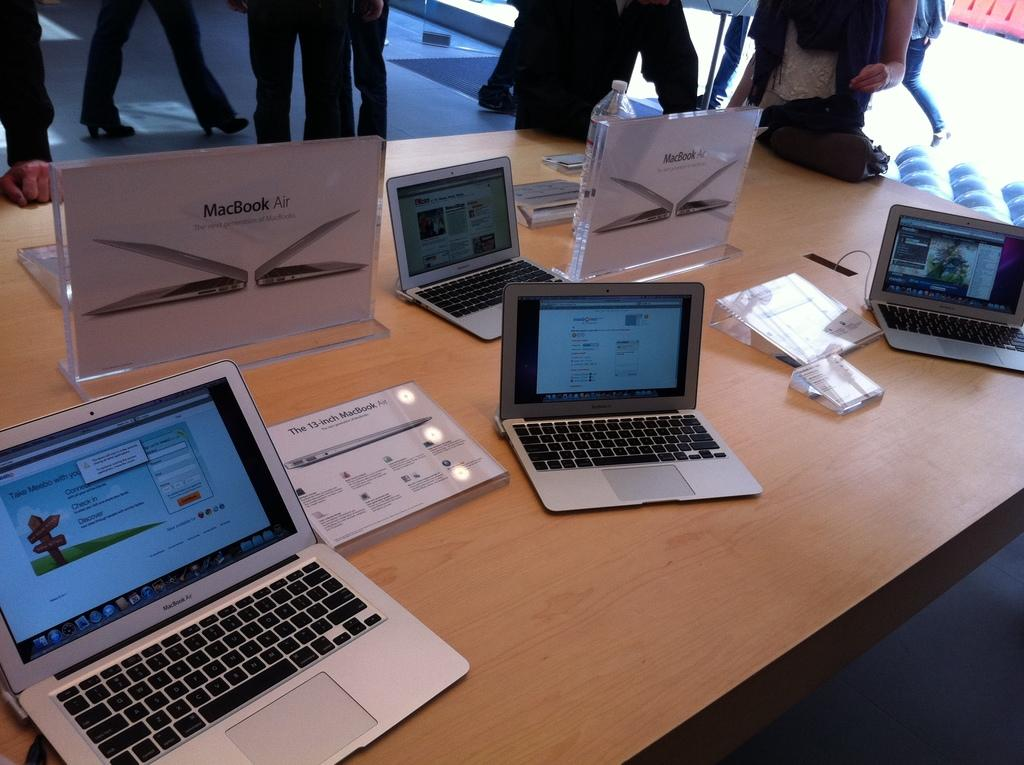<image>
Write a terse but informative summary of the picture. Some laptops are on a table along with an information about the 13 inch Macbook Air. 